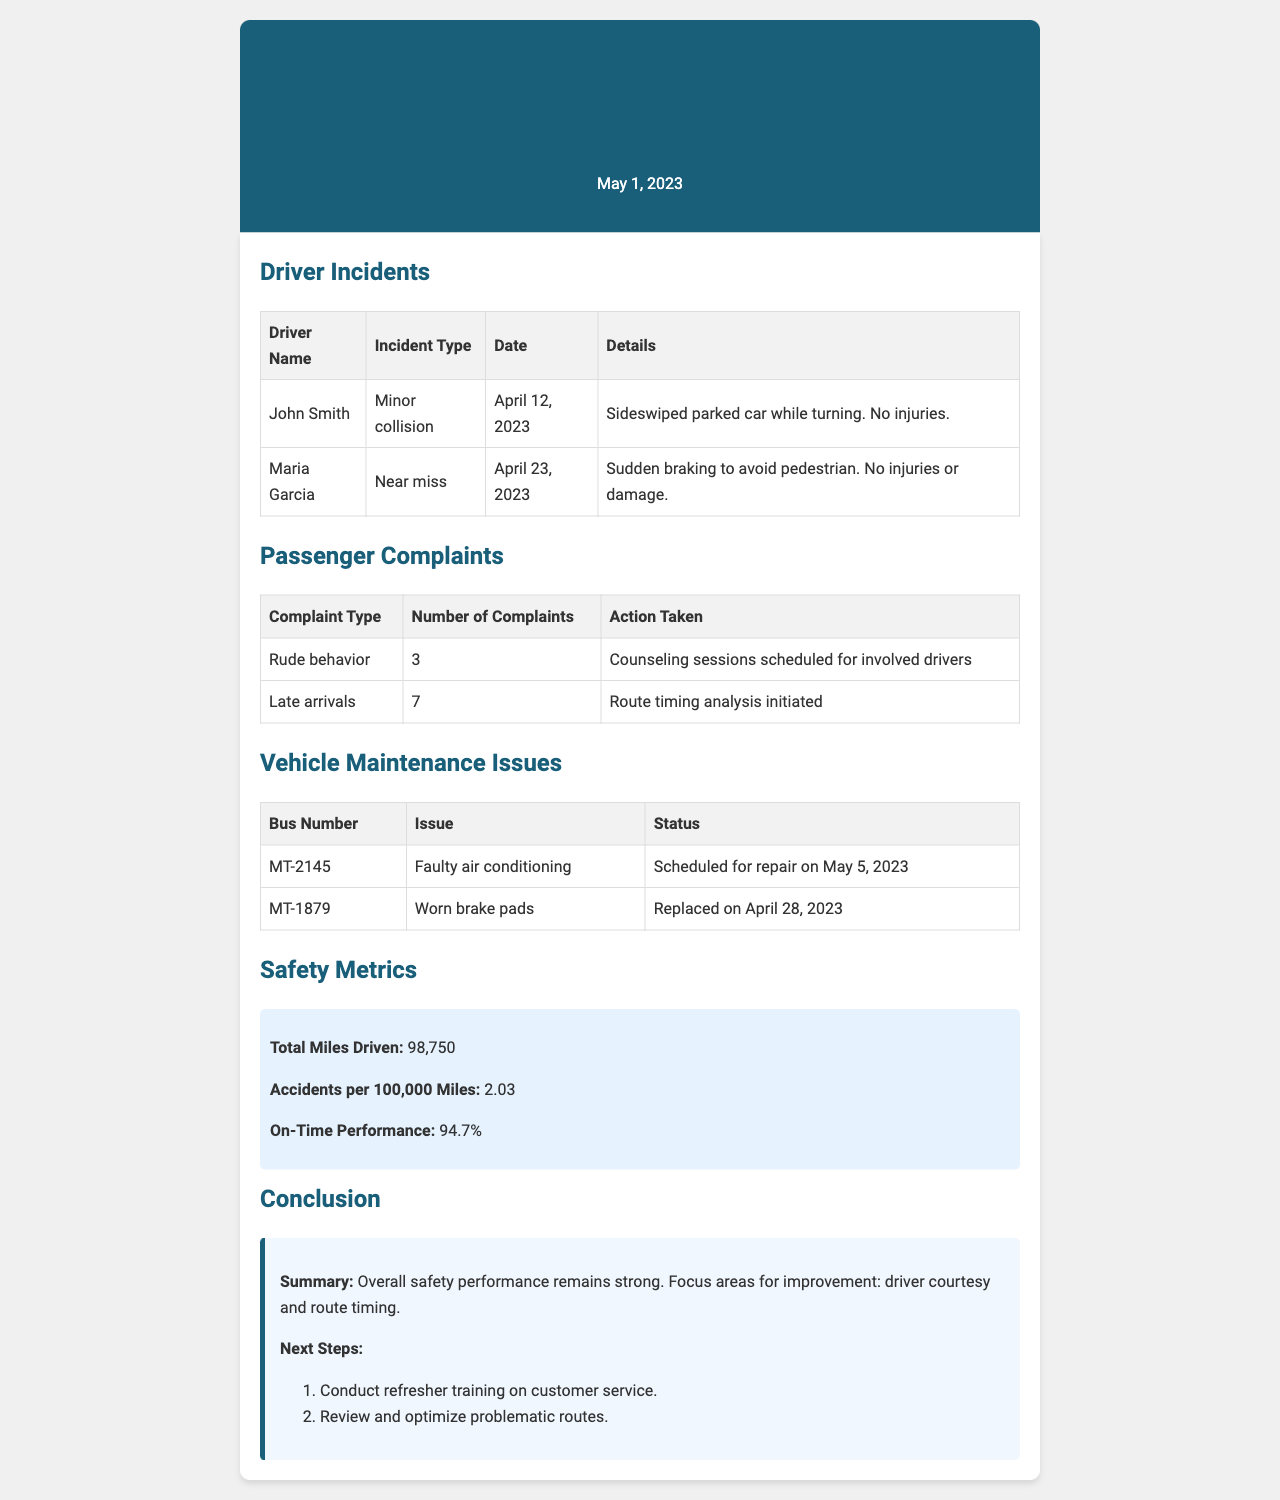What is the date of the report? The report is dated May 1, 2023, as indicated at the top of the document.
Answer: May 1, 2023 How many driver incidents were reported? There are two incidents listed under the Driver Incidents section of the document.
Answer: 2 What type of incident did John Smith experience? According to the document, John Smith was involved in a minor collision.
Answer: Minor collision What action was taken regarding rude behavior complaints? The action taken for rude behavior complaints involved scheduling counseling sessions for the involved drivers.
Answer: Counseling sessions scheduled for involved drivers What was the status of bus MT-2145? The status for bus MT-2145 is that it is scheduled for repair on May 5, 2023.
Answer: Scheduled for repair on May 5, 2023 What is the total miles driven? The document states a total of 98,750 miles were driven this month.
Answer: 98,750 Which area needs improvement according to the conclusion? The conclusion notes that driver courtesy is a focus area for improvement.
Answer: Driver courtesy What was the number of complaints regarding late arrivals? The number of complaints about late arrivals was recorded as 7 in the document.
Answer: 7 What is the on-time performance percentage? The document indicates the on-time performance percentage to be 94.7%.
Answer: 94.7% 